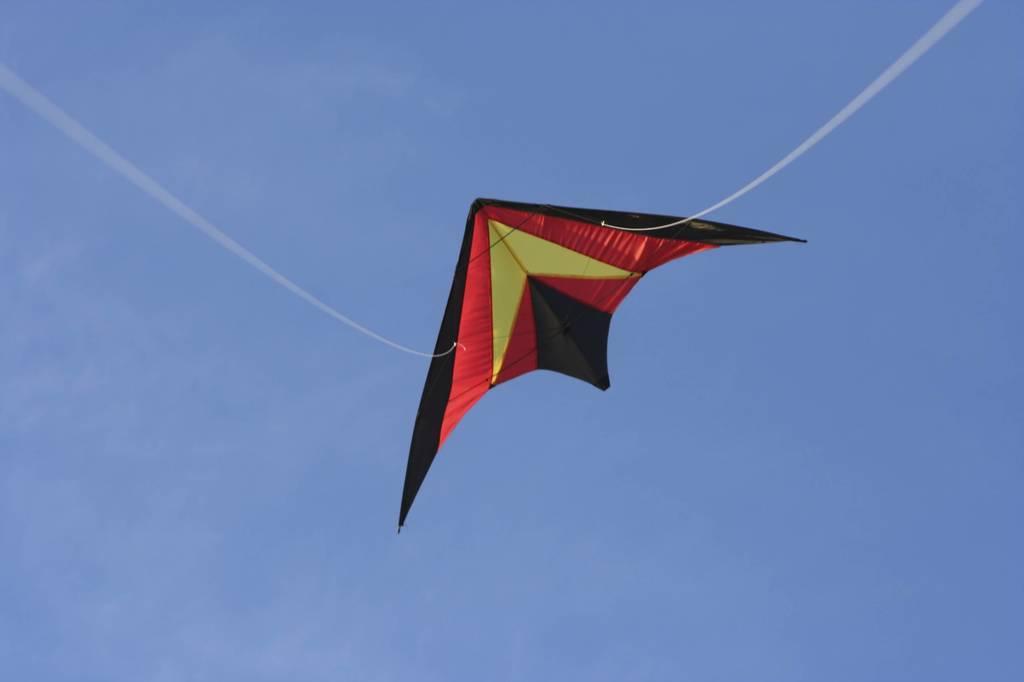How would you summarize this image in a sentence or two? There is a black, red and yellow color kite flying with threads. In the background there is sky. 